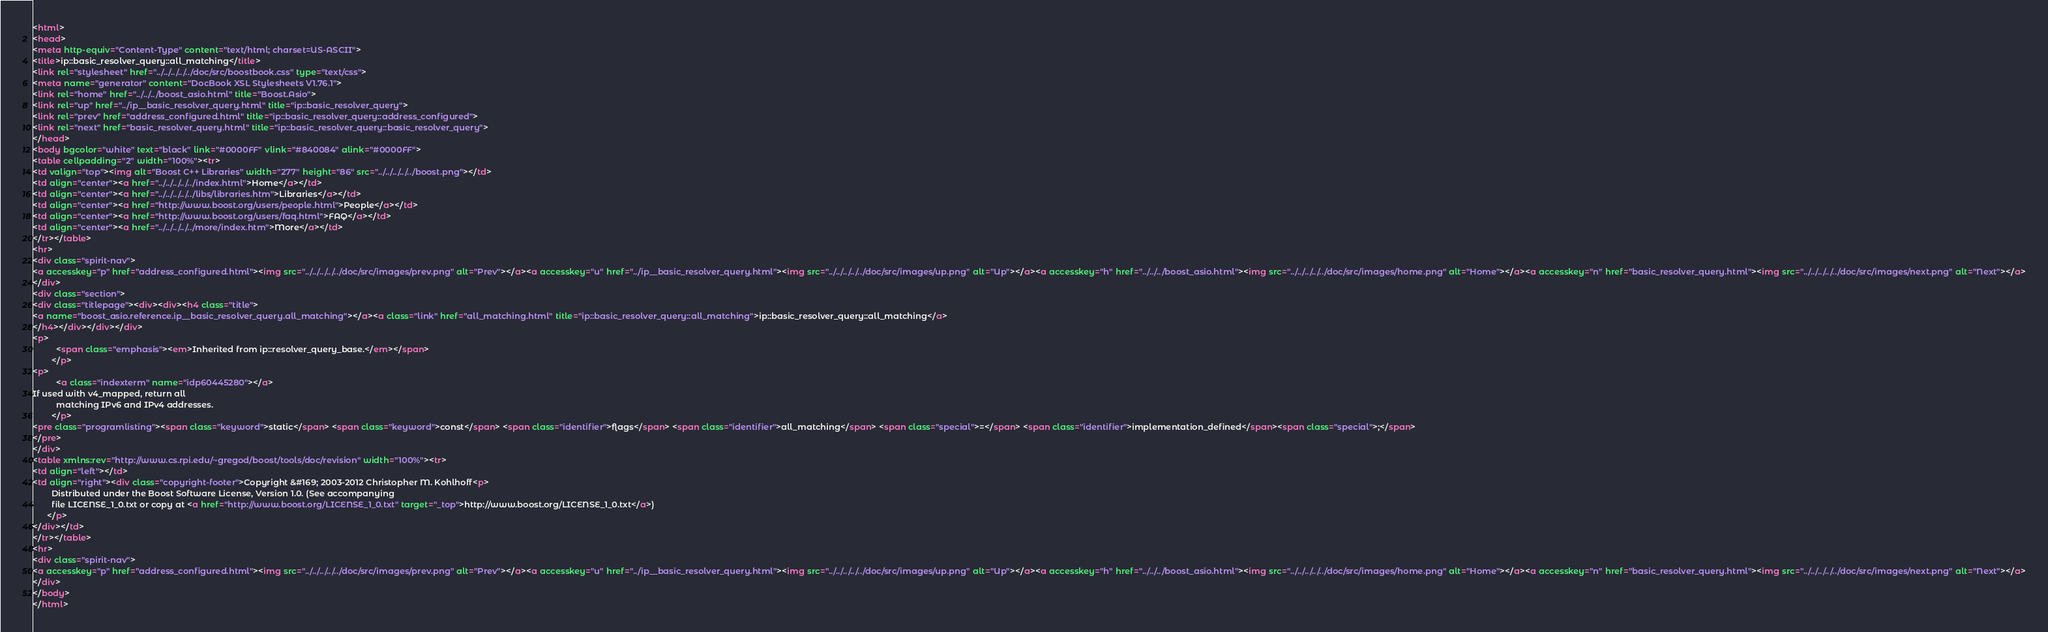Convert code to text. <code><loc_0><loc_0><loc_500><loc_500><_HTML_><html>
<head>
<meta http-equiv="Content-Type" content="text/html; charset=US-ASCII">
<title>ip::basic_resolver_query::all_matching</title>
<link rel="stylesheet" href="../../../../../doc/src/boostbook.css" type="text/css">
<meta name="generator" content="DocBook XSL Stylesheets V1.76.1">
<link rel="home" href="../../../boost_asio.html" title="Boost.Asio">
<link rel="up" href="../ip__basic_resolver_query.html" title="ip::basic_resolver_query">
<link rel="prev" href="address_configured.html" title="ip::basic_resolver_query::address_configured">
<link rel="next" href="basic_resolver_query.html" title="ip::basic_resolver_query::basic_resolver_query">
</head>
<body bgcolor="white" text="black" link="#0000FF" vlink="#840084" alink="#0000FF">
<table cellpadding="2" width="100%"><tr>
<td valign="top"><img alt="Boost C++ Libraries" width="277" height="86" src="../../../../../boost.png"></td>
<td align="center"><a href="../../../../../index.html">Home</a></td>
<td align="center"><a href="../../../../../libs/libraries.htm">Libraries</a></td>
<td align="center"><a href="http://www.boost.org/users/people.html">People</a></td>
<td align="center"><a href="http://www.boost.org/users/faq.html">FAQ</a></td>
<td align="center"><a href="../../../../../more/index.htm">More</a></td>
</tr></table>
<hr>
<div class="spirit-nav">
<a accesskey="p" href="address_configured.html"><img src="../../../../../doc/src/images/prev.png" alt="Prev"></a><a accesskey="u" href="../ip__basic_resolver_query.html"><img src="../../../../../doc/src/images/up.png" alt="Up"></a><a accesskey="h" href="../../../boost_asio.html"><img src="../../../../../doc/src/images/home.png" alt="Home"></a><a accesskey="n" href="basic_resolver_query.html"><img src="../../../../../doc/src/images/next.png" alt="Next"></a>
</div>
<div class="section">
<div class="titlepage"><div><div><h4 class="title">
<a name="boost_asio.reference.ip__basic_resolver_query.all_matching"></a><a class="link" href="all_matching.html" title="ip::basic_resolver_query::all_matching">ip::basic_resolver_query::all_matching</a>
</h4></div></div></div>
<p>
          <span class="emphasis"><em>Inherited from ip::resolver_query_base.</em></span>
        </p>
<p>
          <a class="indexterm" name="idp60445280"></a> 
If used with v4_mapped, return all
          matching IPv6 and IPv4 addresses.
        </p>
<pre class="programlisting"><span class="keyword">static</span> <span class="keyword">const</span> <span class="identifier">flags</span> <span class="identifier">all_matching</span> <span class="special">=</span> <span class="identifier">implementation_defined</span><span class="special">;</span>
</pre>
</div>
<table xmlns:rev="http://www.cs.rpi.edu/~gregod/boost/tools/doc/revision" width="100%"><tr>
<td align="left"></td>
<td align="right"><div class="copyright-footer">Copyright &#169; 2003-2012 Christopher M. Kohlhoff<p>
        Distributed under the Boost Software License, Version 1.0. (See accompanying
        file LICENSE_1_0.txt or copy at <a href="http://www.boost.org/LICENSE_1_0.txt" target="_top">http://www.boost.org/LICENSE_1_0.txt</a>)
      </p>
</div></td>
</tr></table>
<hr>
<div class="spirit-nav">
<a accesskey="p" href="address_configured.html"><img src="../../../../../doc/src/images/prev.png" alt="Prev"></a><a accesskey="u" href="../ip__basic_resolver_query.html"><img src="../../../../../doc/src/images/up.png" alt="Up"></a><a accesskey="h" href="../../../boost_asio.html"><img src="../../../../../doc/src/images/home.png" alt="Home"></a><a accesskey="n" href="basic_resolver_query.html"><img src="../../../../../doc/src/images/next.png" alt="Next"></a>
</div>
</body>
</html>
</code> 